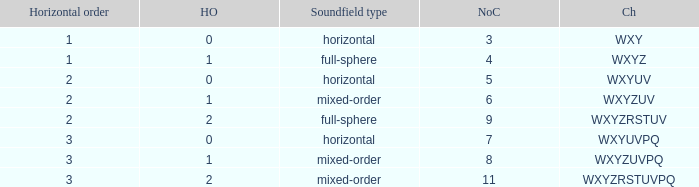If the channels is wxyzrstuvpq, what is the horizontal order? 3.0. Parse the table in full. {'header': ['Horizontal order', 'HO', 'Soundfield type', 'NoC', 'Ch'], 'rows': [['1', '0', 'horizontal', '3', 'WXY'], ['1', '1', 'full-sphere', '4', 'WXYZ'], ['2', '0', 'horizontal', '5', 'WXYUV'], ['2', '1', 'mixed-order', '6', 'WXYZUV'], ['2', '2', 'full-sphere', '9', 'WXYZRSTUV'], ['3', '0', 'horizontal', '7', 'WXYUVPQ'], ['3', '1', 'mixed-order', '8', 'WXYZUVPQ'], ['3', '2', 'mixed-order', '11', 'WXYZRSTUVPQ']]} 